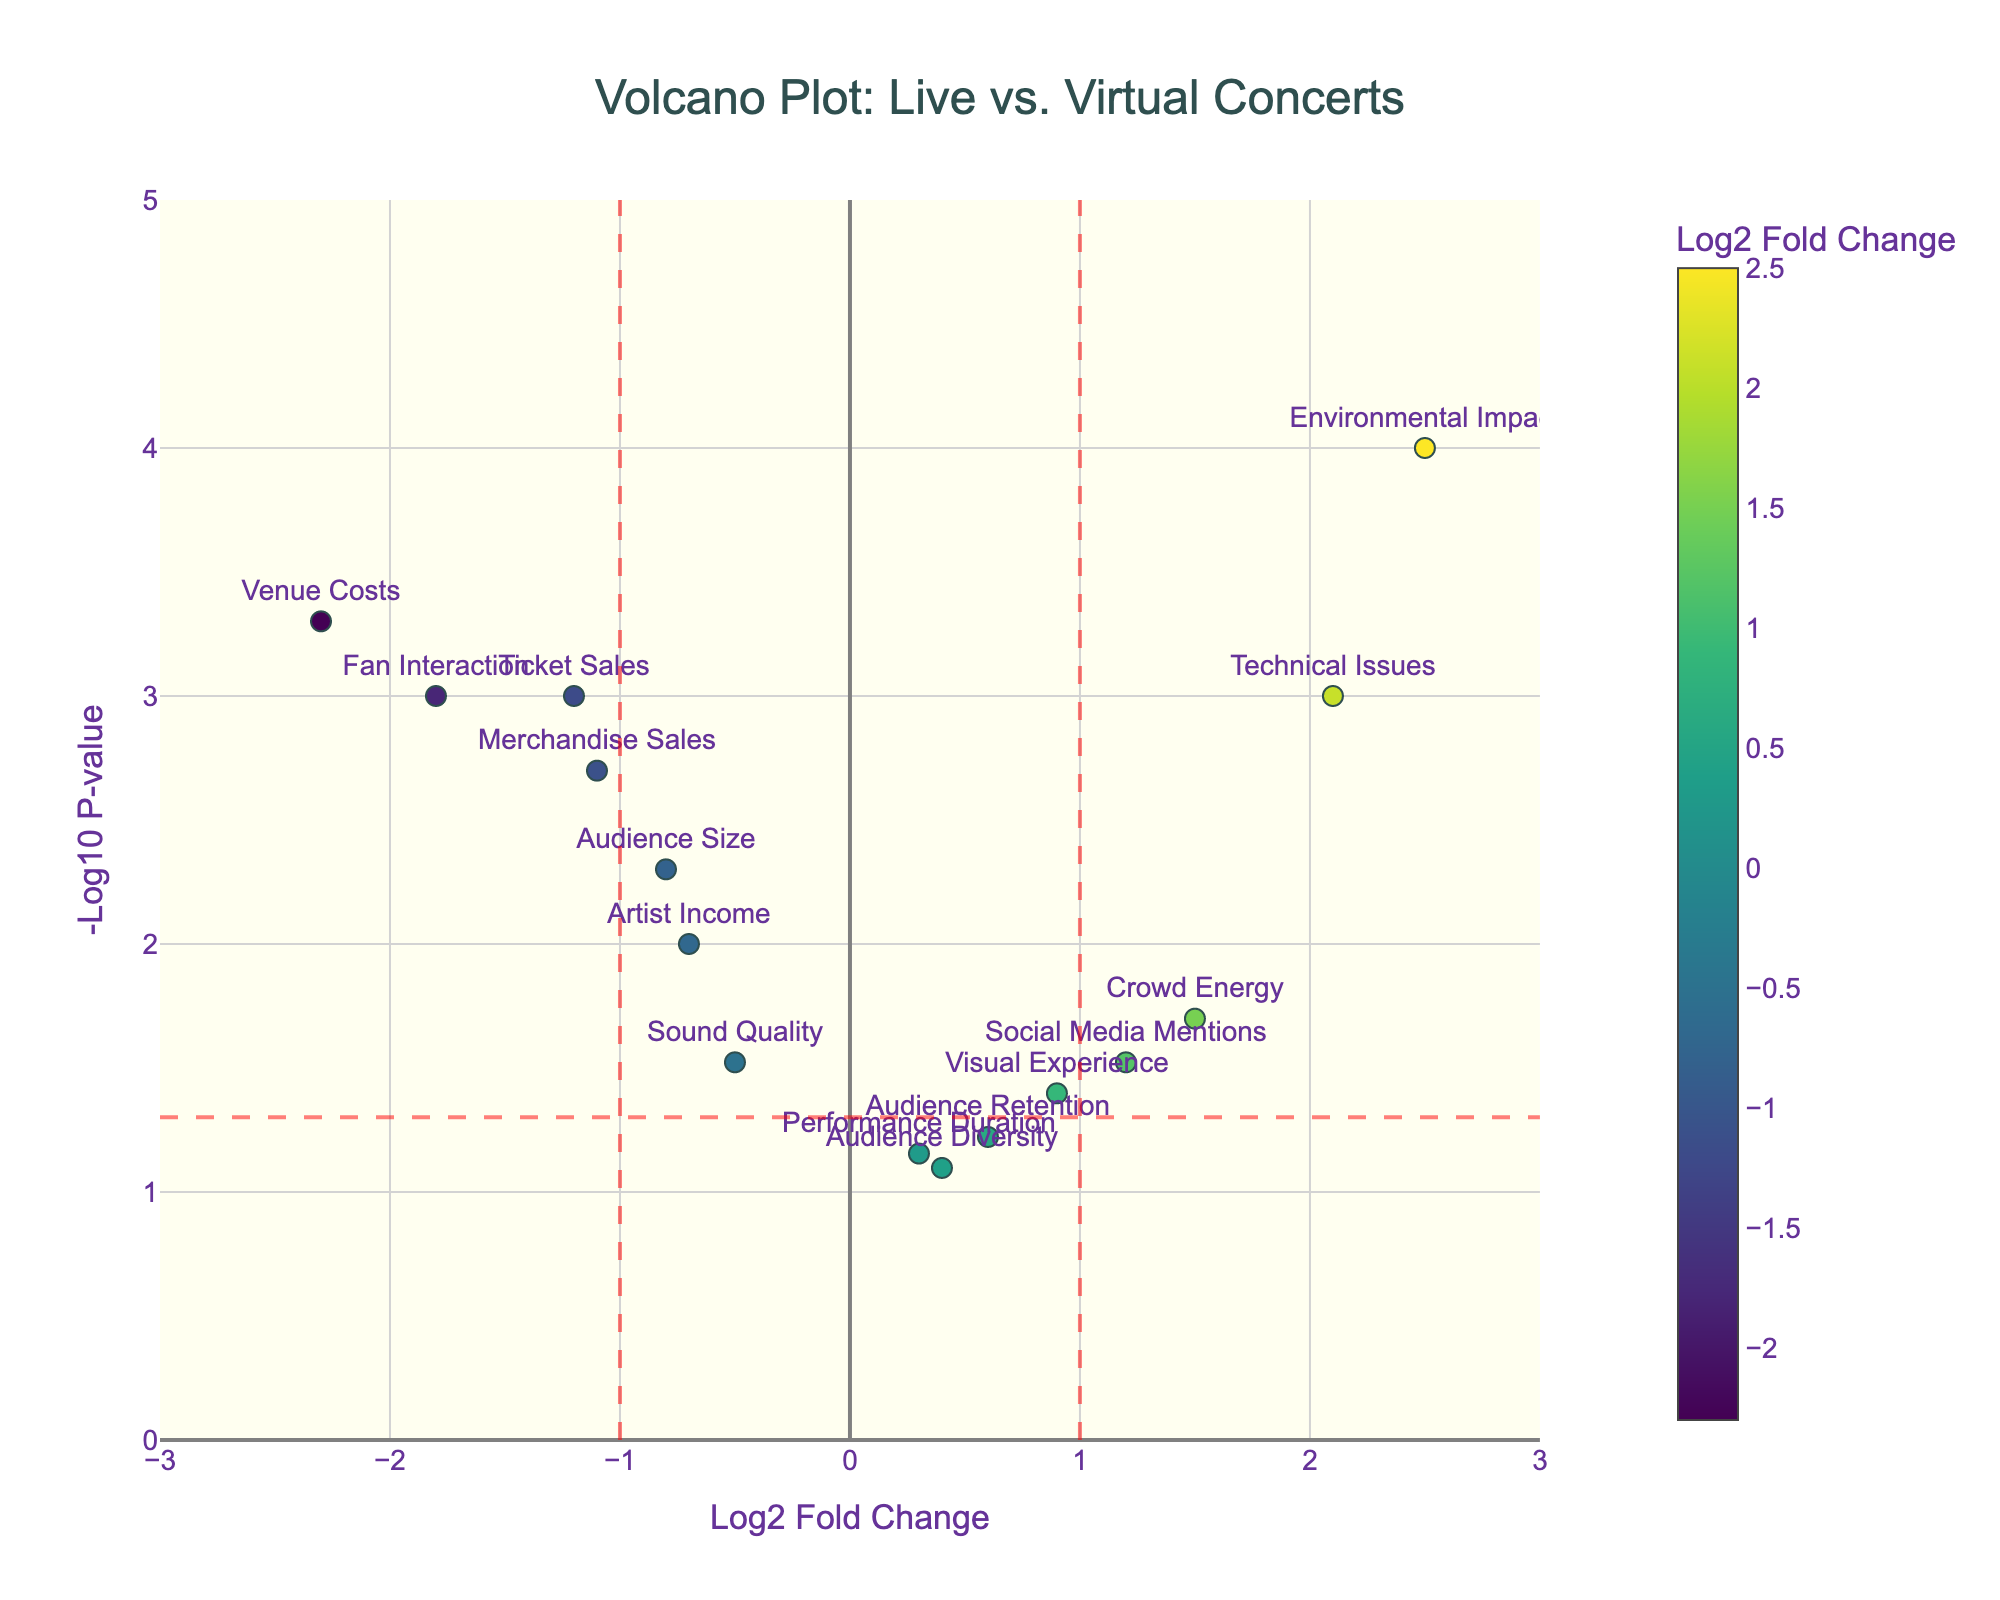What is the title of the plot? The title is usually the main header at the top of the plot, and it explains what the plot represents. Here, it says "Volcano Plot: Live vs. Virtual Concerts".
Answer: Volcano Plot: Live vs. Virtual Concerts What is represented on the x-axis and y-axis? The x-axis represents the "Log2 Fold Change" and the y-axis represents the "-Log10 P-value". These labels are directly noted on the plot's axes.
Answer: Log2 Fold Change and -Log10 P-value How many data points are there on the plot? By counting the markers or looking for the number of entries in the provided data, you will see there are 15 features plotted.
Answer: 15 Which feature has the highest negative log10 p-value? The highest point on the y-axis represents the highest -Log10 P-value. By identifying it, we see the feature "Environmental Impact".
Answer: Environmental Impact Which feature has the highest Log2 Fold Change? The farthest point to the right on the x-axis represents the highest Log2 Fold Change. Here, it is "Environmental Impact".
Answer: Environmental Impact Which feature shows the lowest Log2 Fold Change? The farthest point to the left on the x-axis represents the lowest Log2 Fold Change. Here, it is "Venue Costs".
Answer: Venue Costs Which features are statistically significant (p-value < 0.05)? The plot indicates significant features above the red horizontal line (threshold for p-value < 0.05). By visual inspection, these features include "Ticket Sales", "Audience Size", "Crowd Energy", "Merchandise Sales", "Fan Interaction", "Artist Income", "Technical Issues", "Social Media Mentions", "Visual Experience", "Environmental Impact", and "Venue Costs".
Answer: 11 features (list them) Are there any features with a positive Log2 Fold Change and statistically significant? Positive Log2 Fold Change points are on the right of the center, and they must be above the red horizontal line. These include "Crowd Energy", "Technical Issues", "Social Media Mentions", "Visual Experience", and "Environmental Impact".
Answer: 5 features (list them) Which feature had the most significant increase in Log2 Fold Change? To determine the feature with the most significant increase, look for the highest positive Log2 Fold Change while being statistically significant (above the red horizontal line). This is "Environmental Impact".
Answer: Environmental Impact Which feature has both a negative Log2 Fold Change and is statistically significant? Features with negative Log2 Fold Change are left of the center and must be above the horizontal red line. These include "Ticket Sales", "Audience Size", "Sound Quality", "Merchandise Sales", "Fan Interaction", "Artist Income", and "Venue Costs".
Answer: 7 features (list them) 